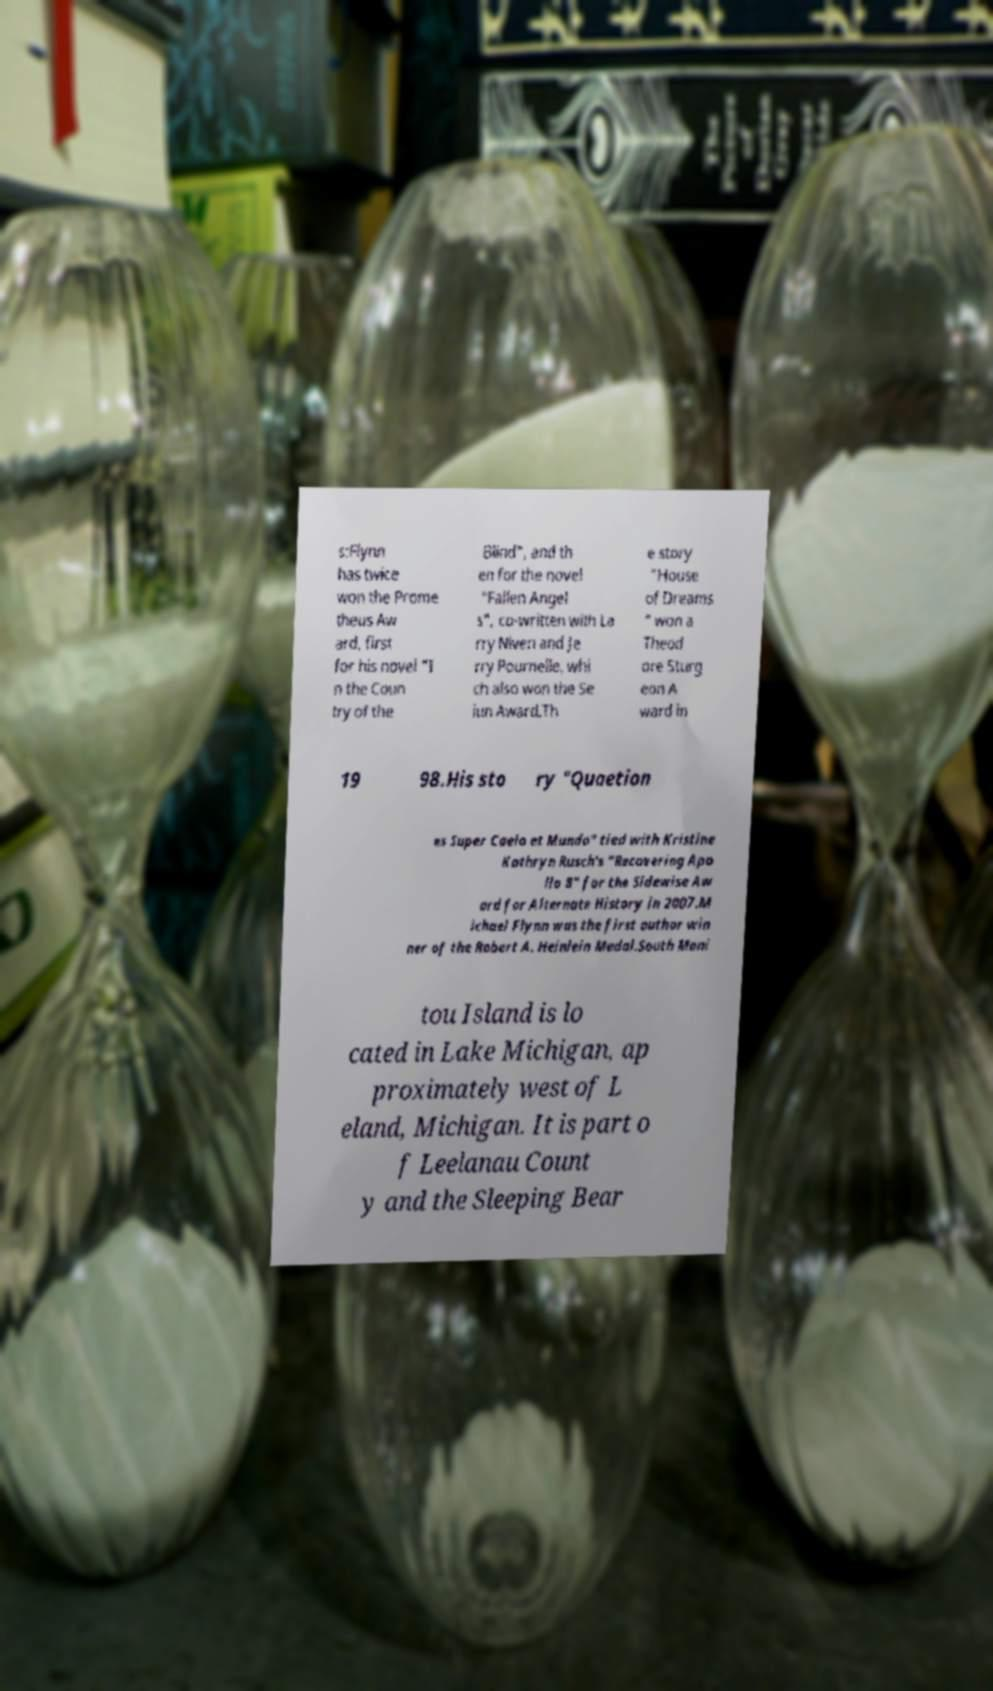There's text embedded in this image that I need extracted. Can you transcribe it verbatim? s:Flynn has twice won the Prome theus Aw ard, first for his novel "I n the Coun try of the Blind", and th en for the novel "Fallen Angel s", co-written with La rry Niven and Je rry Pournelle, whi ch also won the Se iun Award.Th e story "House of Dreams " won a Theod ore Sturg eon A ward in 19 98.His sto ry "Quaetion es Super Caelo et Mundo" tied with Kristine Kathryn Rusch's "Recovering Apo llo 8" for the Sidewise Aw ard for Alternate History in 2007.M ichael Flynn was the first author win ner of the Robert A. Heinlein Medal.South Mani tou Island is lo cated in Lake Michigan, ap proximately west of L eland, Michigan. It is part o f Leelanau Count y and the Sleeping Bear 